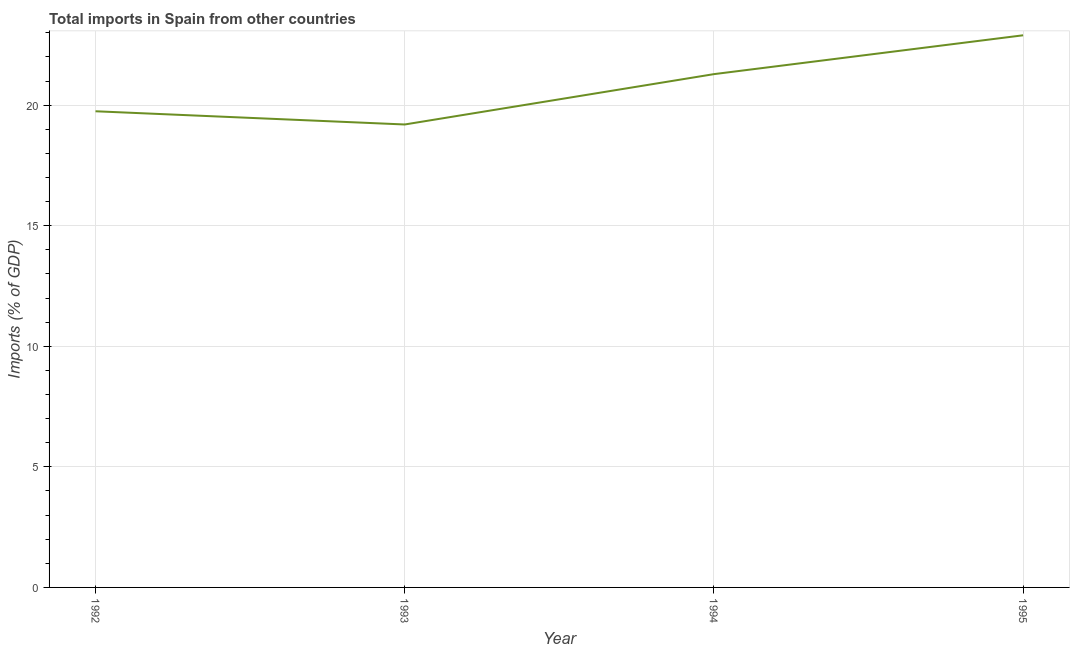What is the total imports in 1994?
Offer a terse response. 21.29. Across all years, what is the maximum total imports?
Offer a terse response. 22.9. Across all years, what is the minimum total imports?
Provide a short and direct response. 19.2. In which year was the total imports minimum?
Ensure brevity in your answer.  1993. What is the sum of the total imports?
Make the answer very short. 83.13. What is the difference between the total imports in 1992 and 1994?
Offer a terse response. -1.54. What is the average total imports per year?
Give a very brief answer. 20.78. What is the median total imports?
Provide a short and direct response. 20.52. In how many years, is the total imports greater than 18 %?
Give a very brief answer. 4. Do a majority of the years between 1994 and 1992 (inclusive) have total imports greater than 14 %?
Give a very brief answer. No. What is the ratio of the total imports in 1992 to that in 1994?
Your answer should be compact. 0.93. What is the difference between the highest and the second highest total imports?
Your response must be concise. 1.61. Is the sum of the total imports in 1992 and 1995 greater than the maximum total imports across all years?
Give a very brief answer. Yes. What is the difference between the highest and the lowest total imports?
Provide a short and direct response. 3.7. How many lines are there?
Your answer should be very brief. 1. How many years are there in the graph?
Keep it short and to the point. 4. What is the difference between two consecutive major ticks on the Y-axis?
Offer a very short reply. 5. Are the values on the major ticks of Y-axis written in scientific E-notation?
Keep it short and to the point. No. Does the graph contain grids?
Your answer should be compact. Yes. What is the title of the graph?
Offer a terse response. Total imports in Spain from other countries. What is the label or title of the X-axis?
Give a very brief answer. Year. What is the label or title of the Y-axis?
Your answer should be very brief. Imports (% of GDP). What is the Imports (% of GDP) in 1992?
Your answer should be very brief. 19.75. What is the Imports (% of GDP) in 1993?
Provide a succinct answer. 19.2. What is the Imports (% of GDP) of 1994?
Make the answer very short. 21.29. What is the Imports (% of GDP) of 1995?
Offer a terse response. 22.9. What is the difference between the Imports (% of GDP) in 1992 and 1993?
Ensure brevity in your answer.  0.55. What is the difference between the Imports (% of GDP) in 1992 and 1994?
Offer a terse response. -1.54. What is the difference between the Imports (% of GDP) in 1992 and 1995?
Your answer should be very brief. -3.15. What is the difference between the Imports (% of GDP) in 1993 and 1994?
Your answer should be very brief. -2.09. What is the difference between the Imports (% of GDP) in 1993 and 1995?
Make the answer very short. -3.7. What is the difference between the Imports (% of GDP) in 1994 and 1995?
Offer a very short reply. -1.61. What is the ratio of the Imports (% of GDP) in 1992 to that in 1993?
Your answer should be very brief. 1.03. What is the ratio of the Imports (% of GDP) in 1992 to that in 1994?
Keep it short and to the point. 0.93. What is the ratio of the Imports (% of GDP) in 1992 to that in 1995?
Your answer should be compact. 0.86. What is the ratio of the Imports (% of GDP) in 1993 to that in 1994?
Offer a very short reply. 0.9. What is the ratio of the Imports (% of GDP) in 1993 to that in 1995?
Your answer should be very brief. 0.84. What is the ratio of the Imports (% of GDP) in 1994 to that in 1995?
Offer a very short reply. 0.93. 